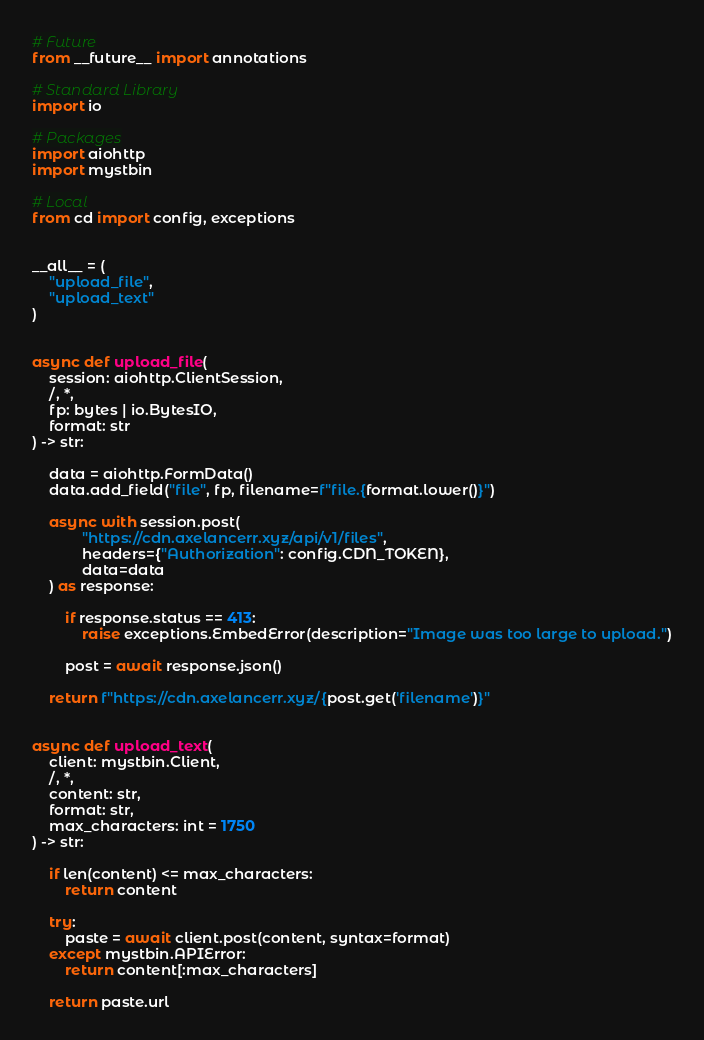<code> <loc_0><loc_0><loc_500><loc_500><_Python_># Future
from __future__ import annotations

# Standard Library
import io

# Packages
import aiohttp
import mystbin

# Local
from cd import config, exceptions


__all__ = (
    "upload_file",
    "upload_text"
)


async def upload_file(
    session: aiohttp.ClientSession,
    /, *,
    fp: bytes | io.BytesIO,
    format: str
) -> str:

    data = aiohttp.FormData()
    data.add_field("file", fp, filename=f"file.{format.lower()}")

    async with session.post(
            "https://cdn.axelancerr.xyz/api/v1/files",
            headers={"Authorization": config.CDN_TOKEN},
            data=data
    ) as response:

        if response.status == 413:
            raise exceptions.EmbedError(description="Image was too large to upload.")

        post = await response.json()

    return f"https://cdn.axelancerr.xyz/{post.get('filename')}"


async def upload_text(
    client: mystbin.Client,
    /, *,
    content: str,
    format: str,
    max_characters: int = 1750
) -> str:

    if len(content) <= max_characters:
        return content

    try:
        paste = await client.post(content, syntax=format)
    except mystbin.APIError:
        return content[:max_characters]

    return paste.url
</code> 